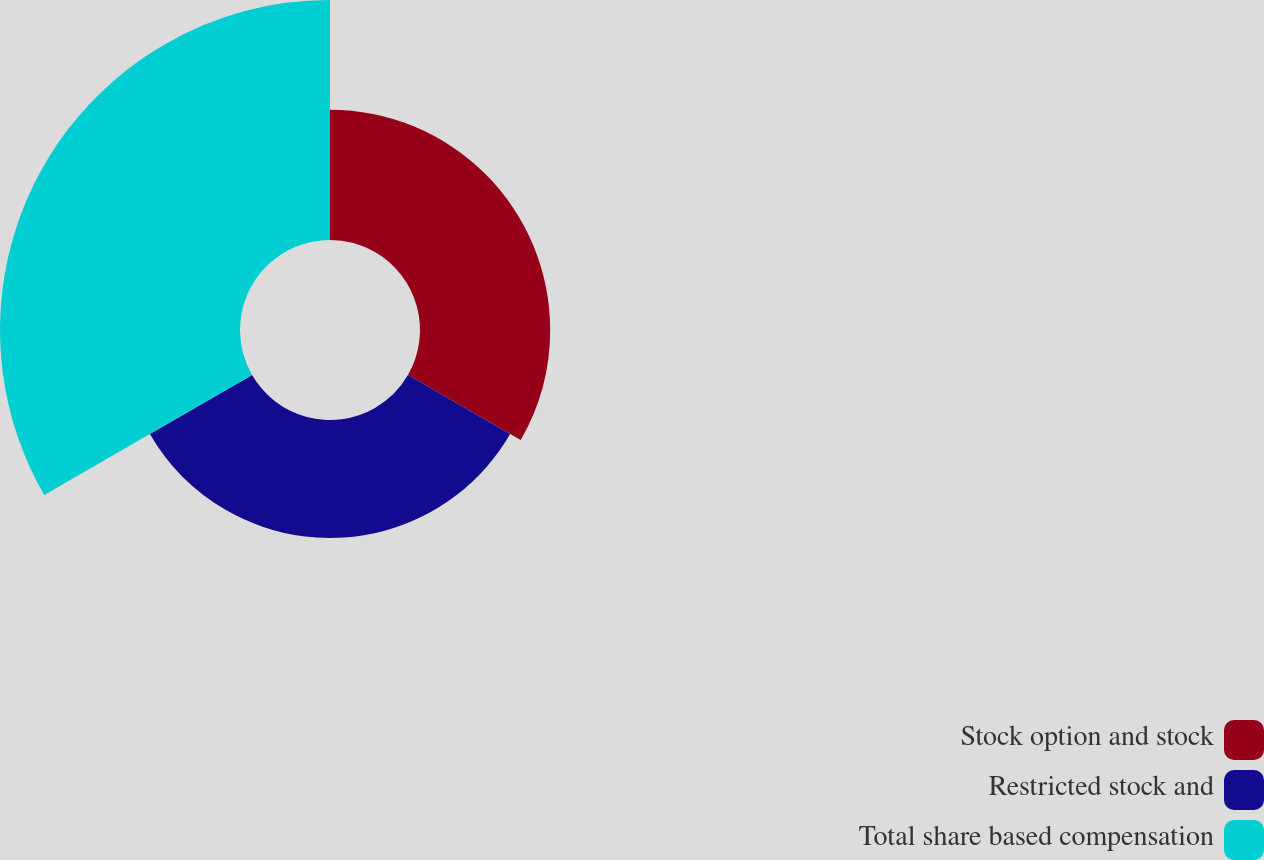Convert chart to OTSL. <chart><loc_0><loc_0><loc_500><loc_500><pie_chart><fcel>Stock option and stock<fcel>Restricted stock and<fcel>Total share based compensation<nl><fcel>26.67%<fcel>24.17%<fcel>49.17%<nl></chart> 